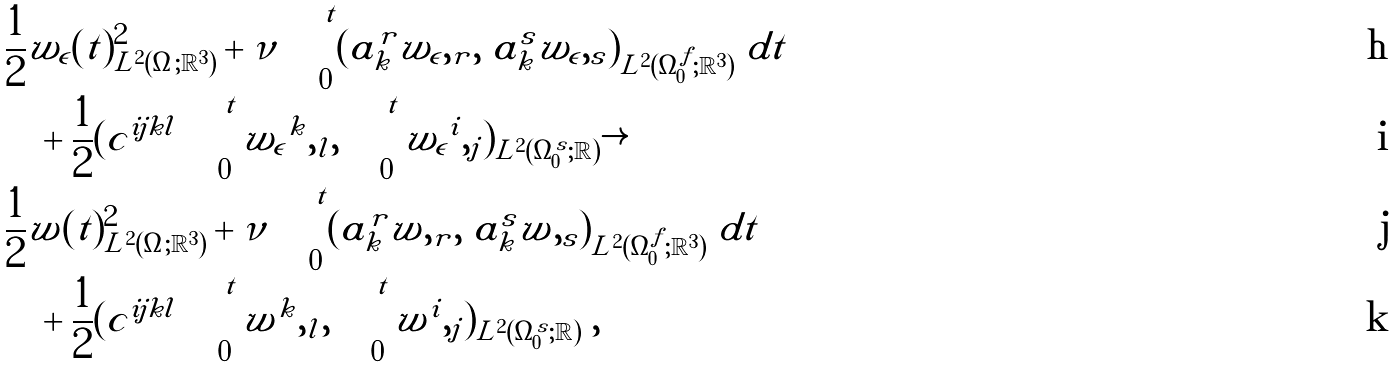<formula> <loc_0><loc_0><loc_500><loc_500>& \frac { 1 } { 2 } \| { w _ { \epsilon } } ( t ) \| ^ { 2 } _ { L ^ { 2 } ( \Omega ; { \mathbb { R } } ^ { 3 } ) } + \nu \int _ { 0 } ^ { t } ( \tilde { a } _ { k } ^ { r } { w _ { \epsilon } } , _ { r } , \ \tilde { a } _ { k } ^ { s } { w _ { \epsilon } } , _ { s } ) _ { L ^ { 2 } ( \Omega _ { 0 } ^ { f } ; { \mathbb { R } } ^ { 3 } ) } \ d t \\ & \quad + \frac { 1 } { 2 } ( c ^ { i j k l } \int _ { 0 } ^ { t } { w _ { \epsilon } } ^ { k } , _ { l } , \int _ { 0 } ^ { t } { w _ { \epsilon } } ^ { i } , _ { j } ) _ { L ^ { 2 } ( \Omega _ { 0 } ^ { s } ; { \mathbb { R } } ) } \rightarrow \\ & \frac { 1 } { 2 } \| \tilde { w } ( t ) \| ^ { 2 } _ { L ^ { 2 } ( \Omega ; { \mathbb { R } } ^ { 3 } ) } + \nu \int _ { 0 } ^ { t } ( \tilde { a } _ { k } ^ { r } \tilde { w } , _ { r } , \ \tilde { a } _ { k } ^ { s } \tilde { w } , _ { s } ) _ { L ^ { 2 } ( \Omega _ { 0 } ^ { f } ; { \mathbb { R } } ^ { 3 } ) } \ d t \\ & \quad + \frac { 1 } { 2 } ( c ^ { i j k l } \int _ { 0 } ^ { t } \tilde { w } ^ { k } , _ { l } , \int _ { 0 } ^ { t } \tilde { w } ^ { i } , _ { j } ) _ { L ^ { 2 } ( \Omega _ { 0 } ^ { s } ; { \mathbb { R } } ) } \ ,</formula> 